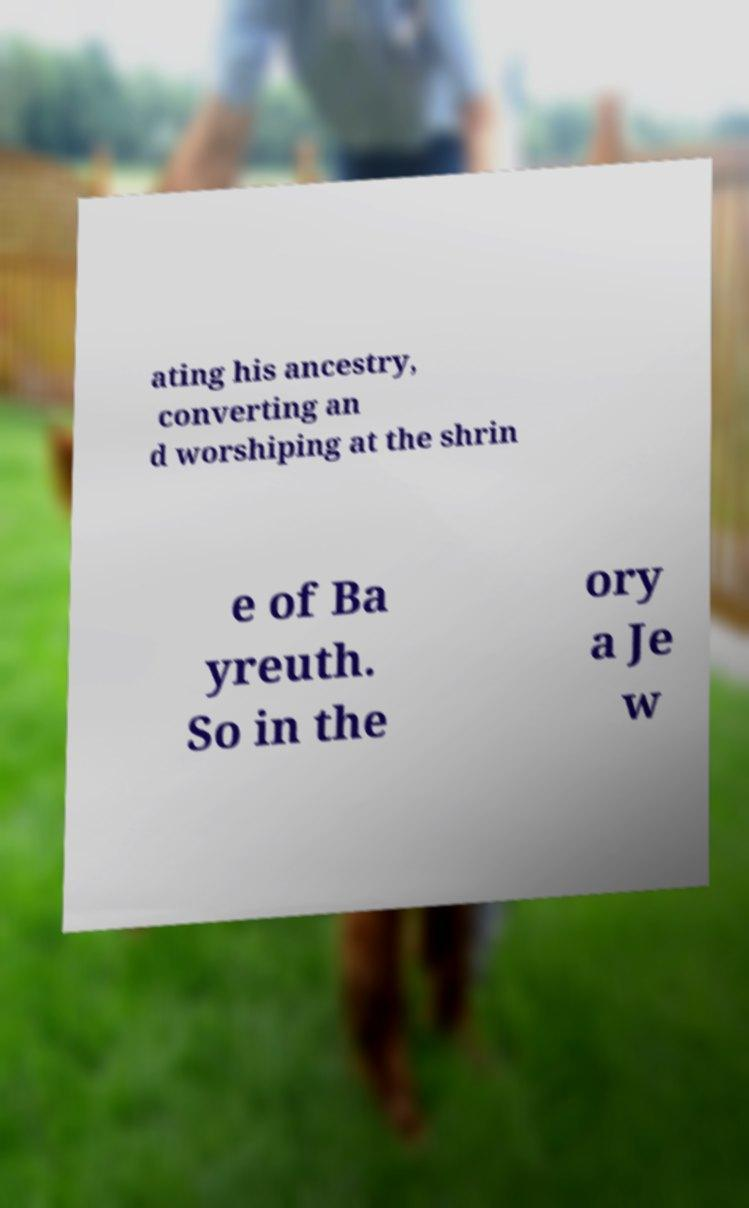Can you read and provide the text displayed in the image?This photo seems to have some interesting text. Can you extract and type it out for me? ating his ancestry, converting an d worshiping at the shrin e of Ba yreuth. So in the ory a Je w 